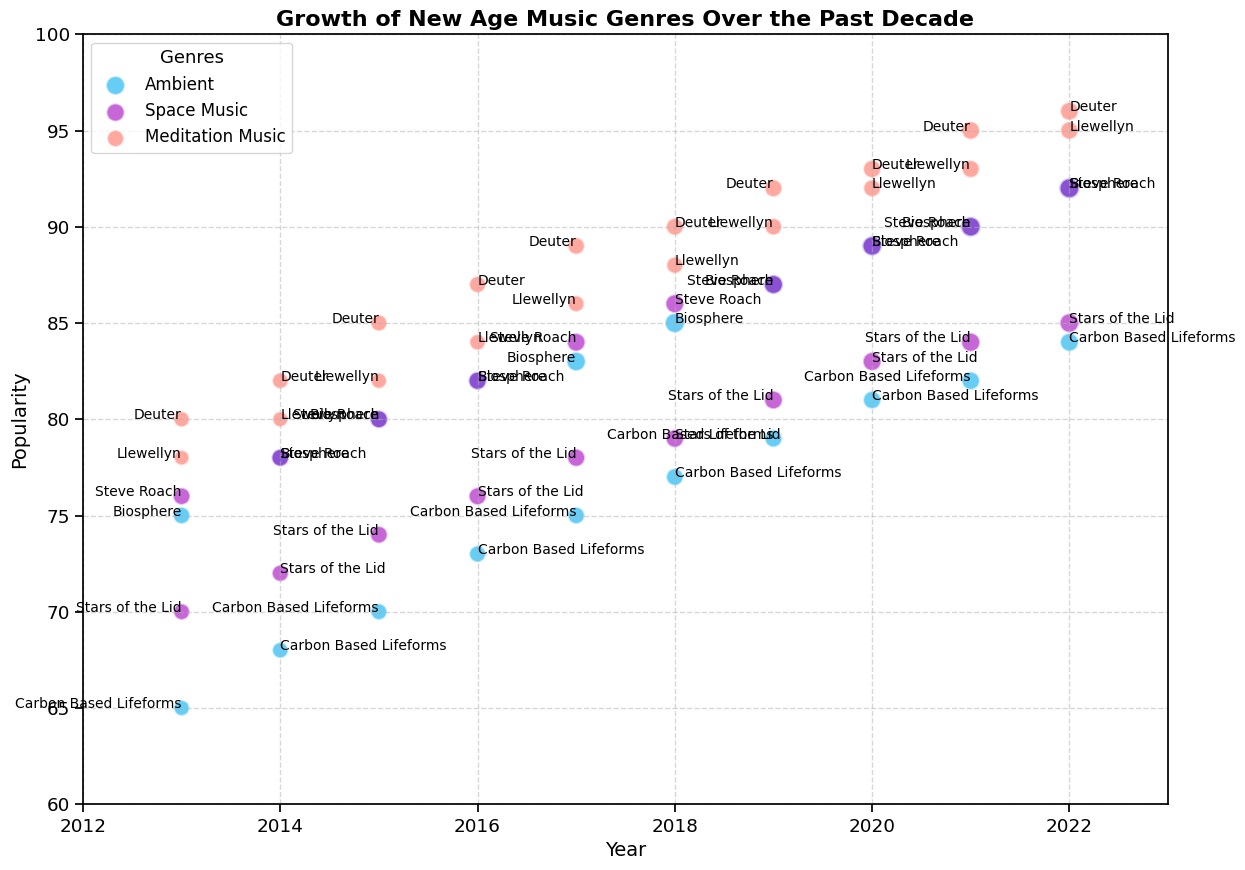What's the most popular artist in 2022? In the year 2022, find the data points by looking at the popularity axis and identify the highest point which indicates the most popular artist.
Answer: Deuter Which genre shows the largest bubble in 2019? Look at the size of the bubbles in 2019. The largest bubble indicates the highest sales. Compare the sizes of the bubbles for each genre in that year.
Answer: Space Music (Steve Roach) What's the difference in popularity between the most and least popular artist in 2016? Identify the popularity of the most popular artist and the least popular artist by looking at the height of the data points on the popularity axis for the year 2016. Subtract the smallest value from the largest value.
Answer: 87 - 73 = 14 Which genre has shown the most significant growth in popularity from 2013 to 2022? For each genre, compare the popularity values from 2013 to 2022. Look for the genre with the largest increase in terms of popularity.
Answer: Meditation Music How does the sales figure of 'Biosphere' in 2022 compare to 'Steve Roach' in the same year? Identify the sales figures for Biosphere and Steve Roach in 2022 by looking at the bubble sizes and then compare the values.
Answer: 240,000 vs. 200,000 (Biosphere is higher) Which year did Deuter achieve a popularity of 95? Identify Deuter's data points and look for the year corresponding to the popularity value of 95.
Answer: 2021 Is there a correlation between sales and popularity for 'Sounds of the Lid' in Space Music over the decade? Look at the trend of both popularity and sales for 'Sounds of the Lid.' Check if both metrics increase, decrease, or show any clear relationship over the years.
Answer: Yes, both sales and popularity generally increase over the years Which artist in the Ambient genre shows the greatest increase in popularity from 2013 to 2022? Find the artists in the Ambient genre and calculate the difference in popularity from 2013 to 2022 for each artist. Identify the artist with the largest increase.
Answer: Biosphere What trends do you observe in the genre of Meditation Music over the decade? Look at the data points for Meditation Music for each year. Note the changes in popularity and sales over the period.
Answer: Increasing trend in both popularity and sales 